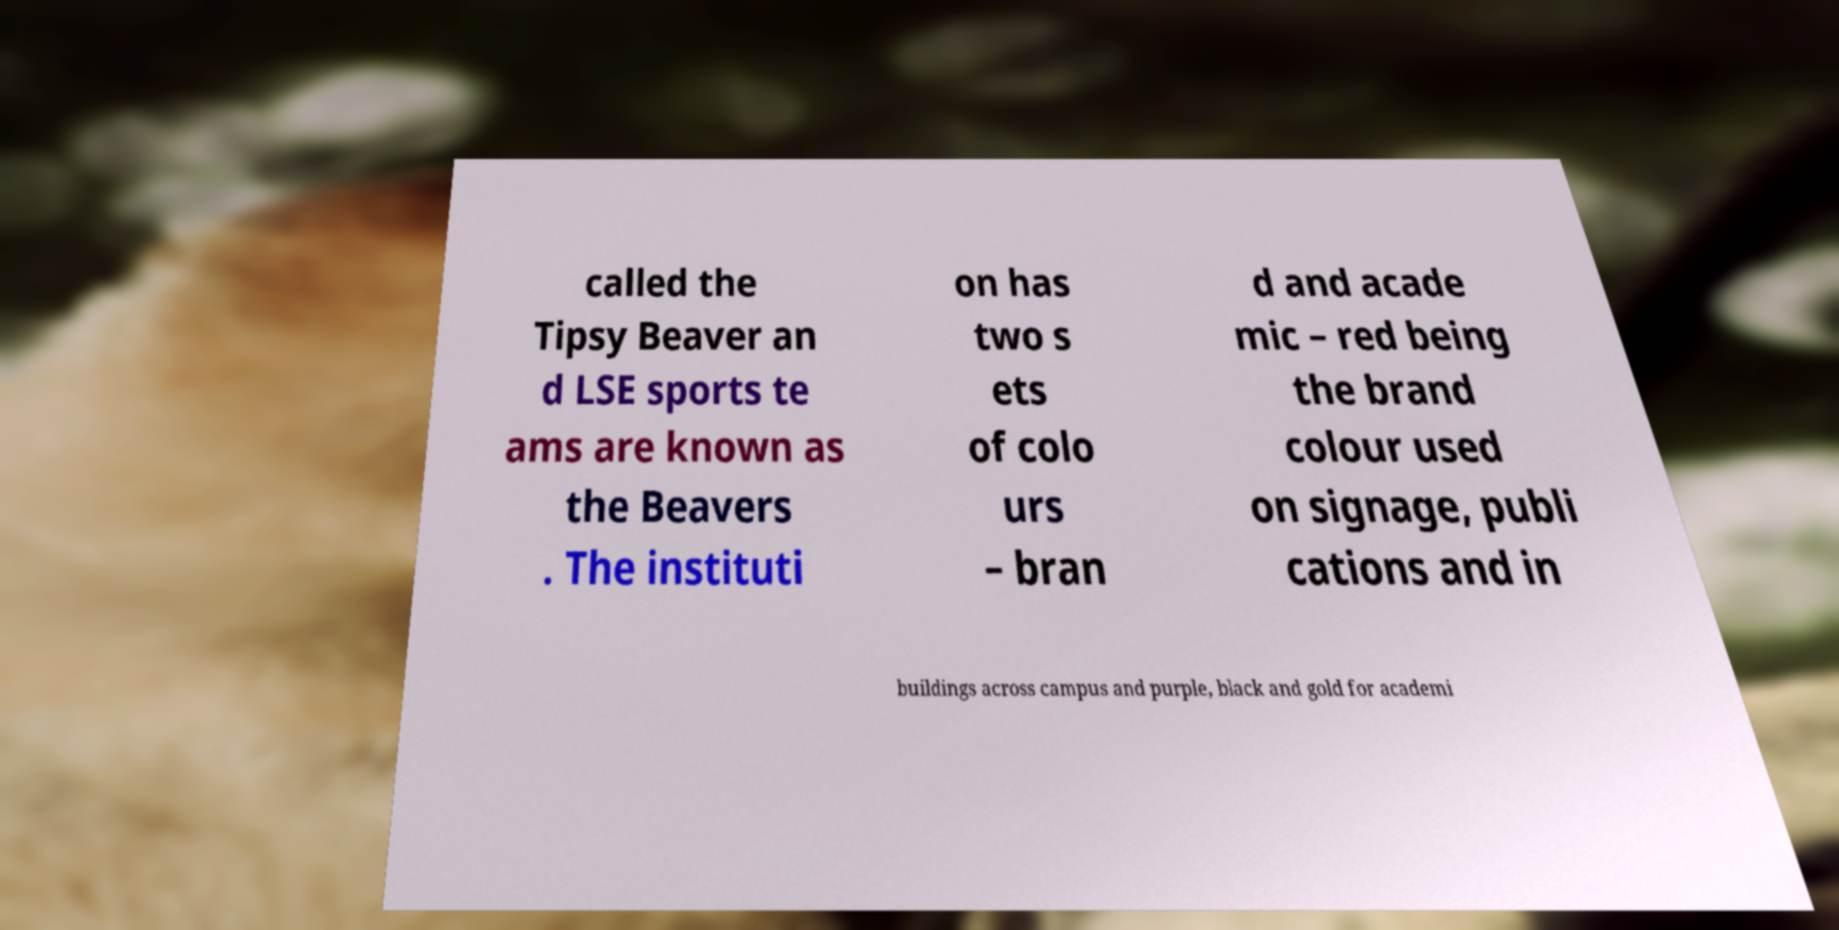What messages or text are displayed in this image? I need them in a readable, typed format. called the Tipsy Beaver an d LSE sports te ams are known as the Beavers . The instituti on has two s ets of colo urs – bran d and acade mic – red being the brand colour used on signage, publi cations and in buildings across campus and purple, black and gold for academi 